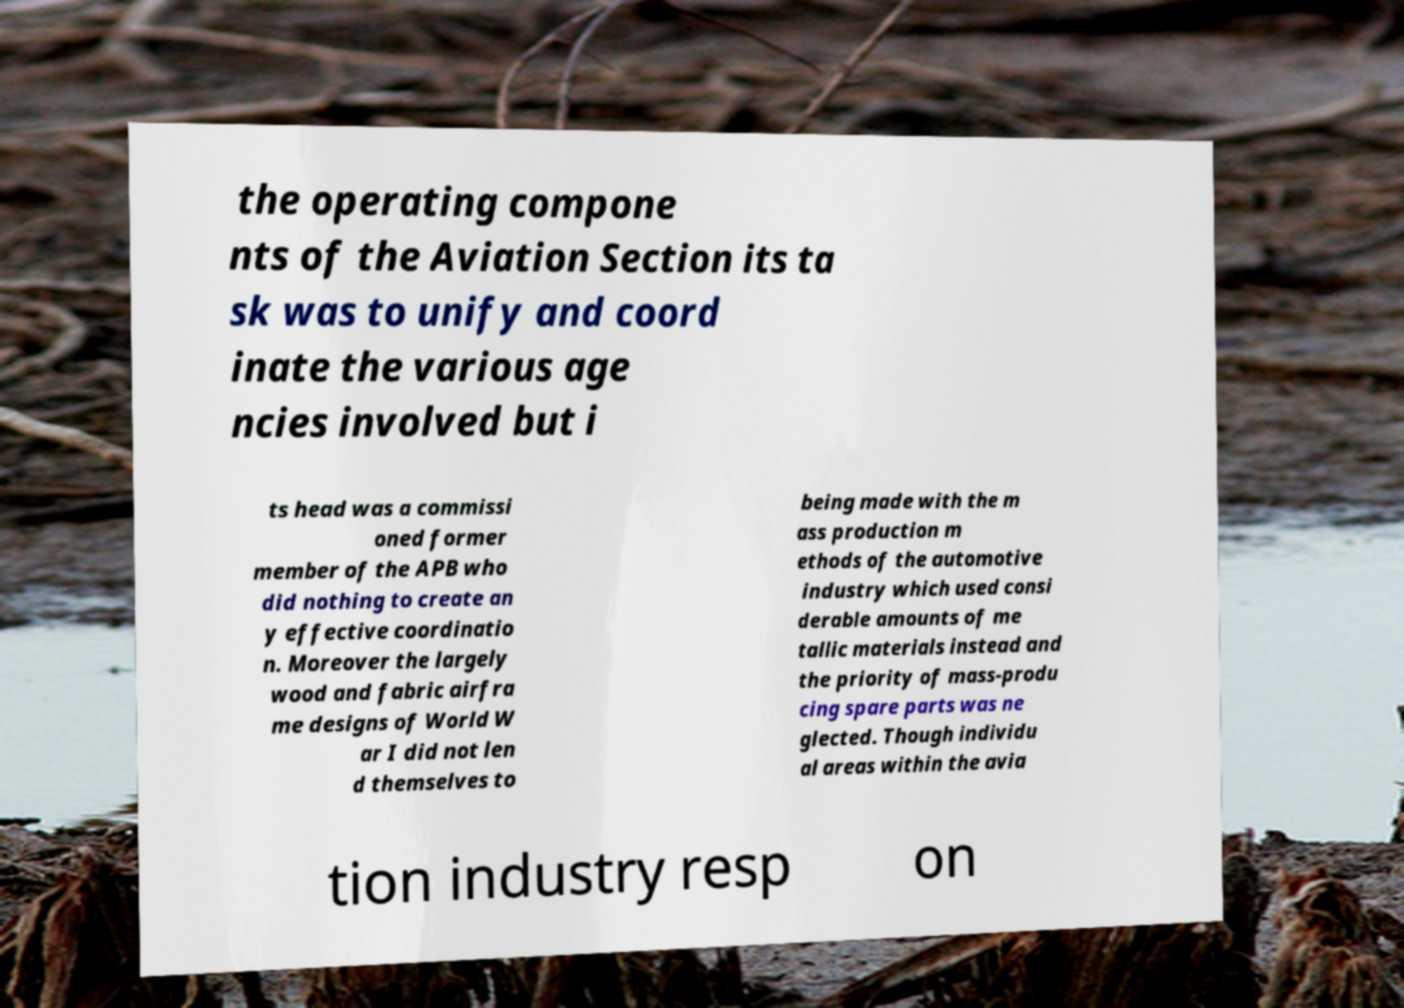Can you accurately transcribe the text from the provided image for me? the operating compone nts of the Aviation Section its ta sk was to unify and coord inate the various age ncies involved but i ts head was a commissi oned former member of the APB who did nothing to create an y effective coordinatio n. Moreover the largely wood and fabric airfra me designs of World W ar I did not len d themselves to being made with the m ass production m ethods of the automotive industry which used consi derable amounts of me tallic materials instead and the priority of mass-produ cing spare parts was ne glected. Though individu al areas within the avia tion industry resp on 